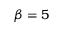Convert formula to latex. <formula><loc_0><loc_0><loc_500><loc_500>\beta = 5</formula> 